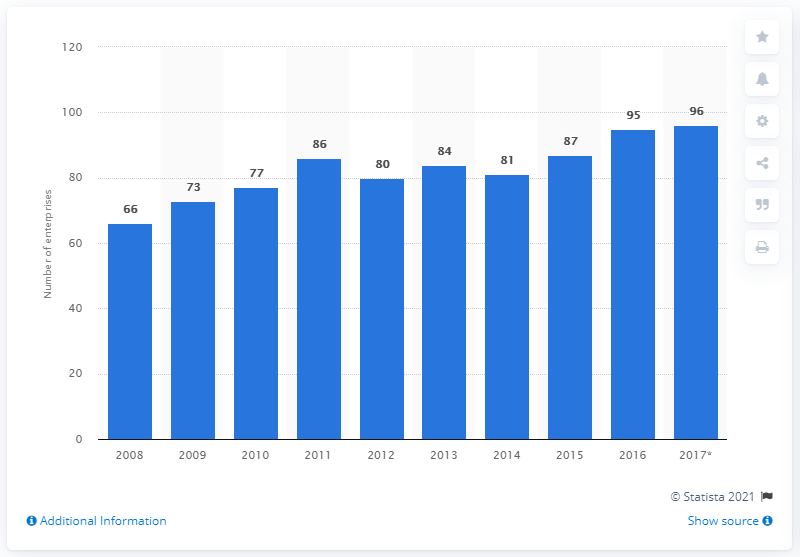Outline some significant characteristics in this image. In 2016, there were 95 enterprises in Denmark that specialized in the production of games and toys. 